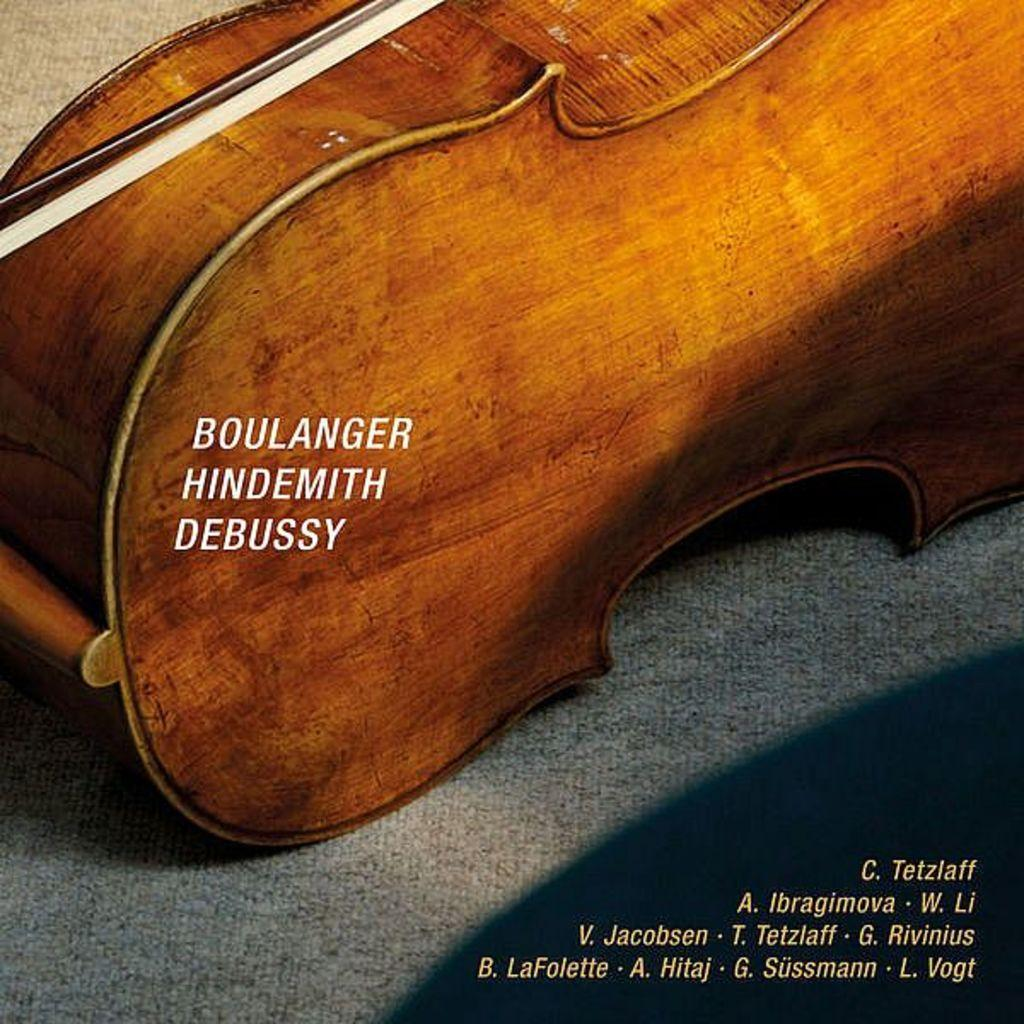What object is made of wood in the image? There is a wooden box in the image. What is written or printed on the wooden box? There are words on the wooden box. What type of knife is used to cut the fuel in the image? There is no knife or fuel present in the image; it only features a wooden box with words on it. 